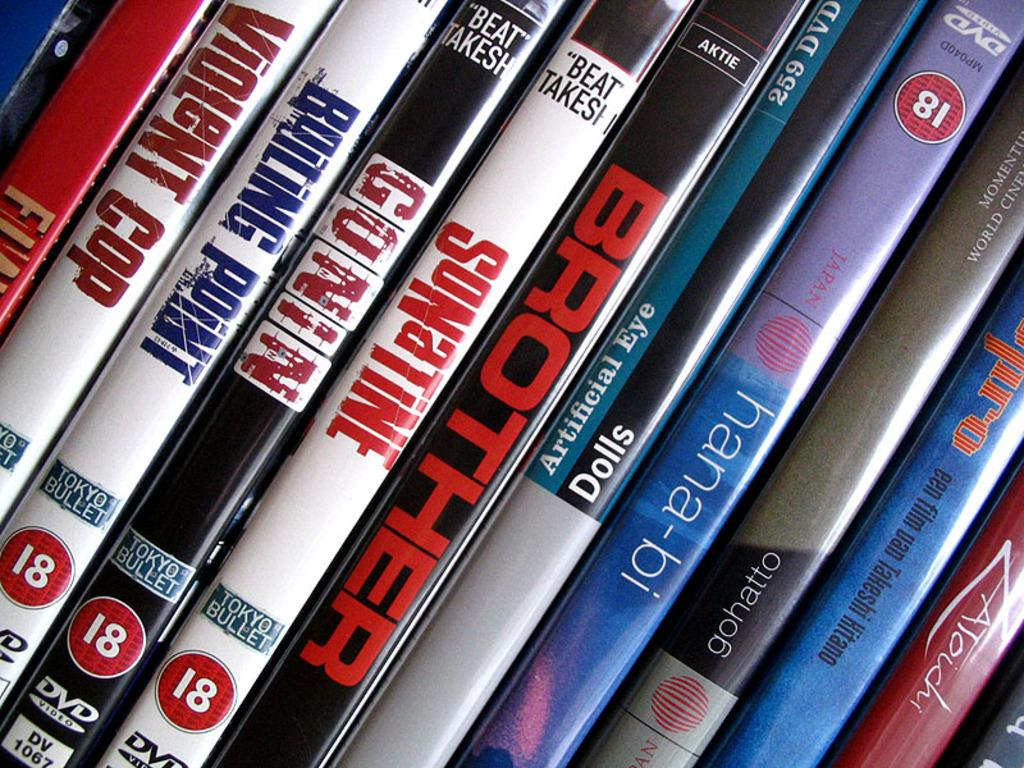Provide a one-sentence caption for the provided image. Some Tokyo Bullet DVDs include titles such as Violent Cop, Boiling Point and Son a Time. 